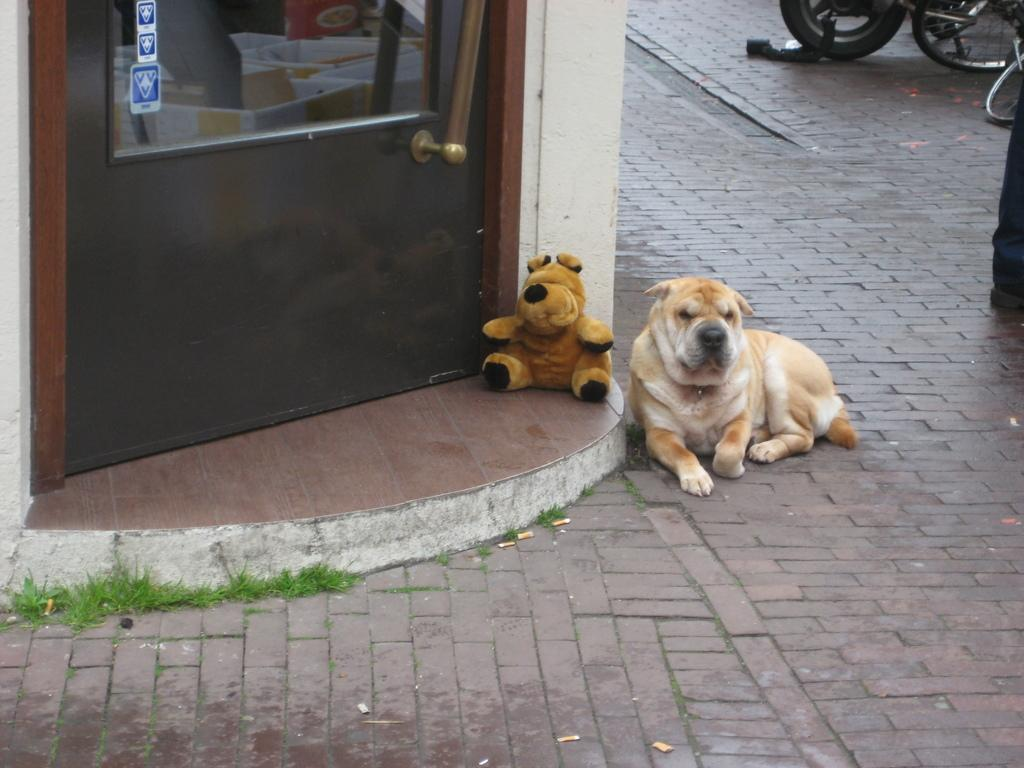What type of animal is in the image? There is a dog in the image. Can you describe the appearance of the dog? The dog is brown and white in color. Where is the dog located in the image? The dog is on the road. What is visible near the door in the image? There is a toy in front of the door. What can be seen in the background of the image? There are vehicles in the background of the image. How many beads are hanging from the pipe in the image? There is no pipe or beads present in the image. What type of chairs can be seen in the image? There are no chairs visible in the image. 